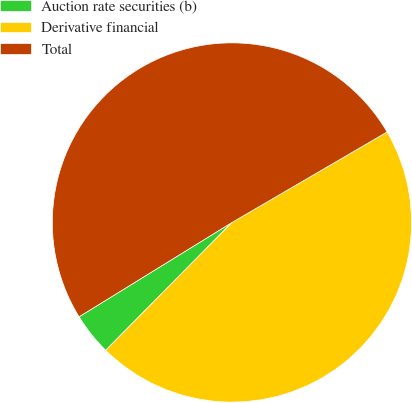<chart> <loc_0><loc_0><loc_500><loc_500><pie_chart><fcel>Auction rate securities (b)<fcel>Derivative financial<fcel>Total<nl><fcel>3.8%<fcel>45.81%<fcel>50.39%<nl></chart> 